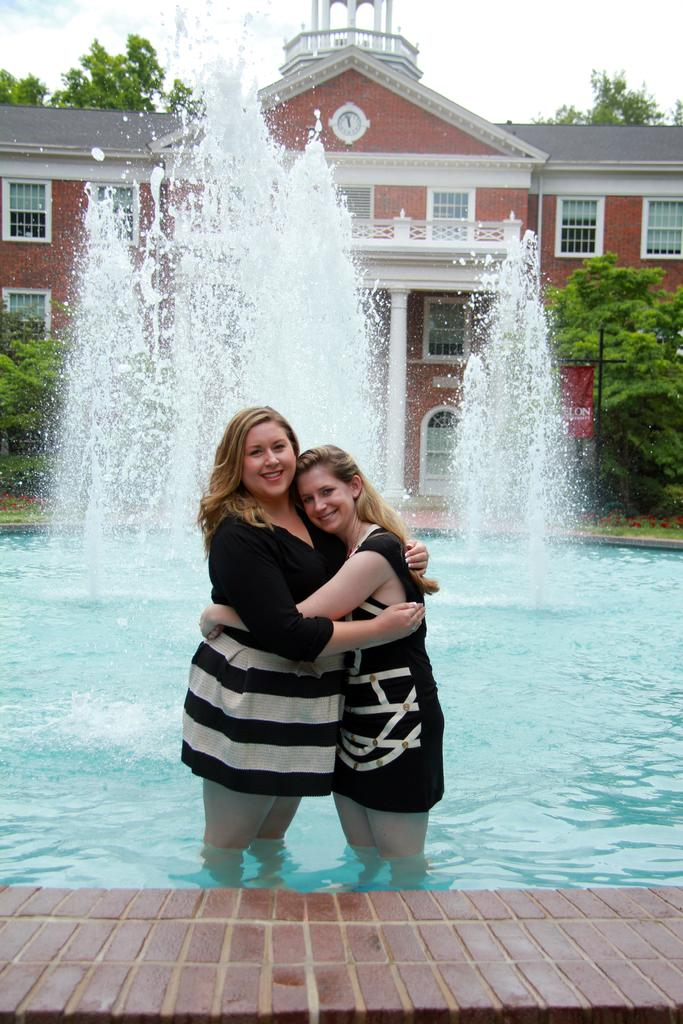How many people are in the image? There are two people in the image. What are the people doing in the image? The people are standing in a fountain. What can be seen in the background of the image? There are trees and a building in the background of the image. What type of plants are attacking the people in the image? There are no plants attacking the people in the image; the people are standing in a fountain. What is the health status of the people in the image? The health status of the people in the image cannot be determined from the image alone. 